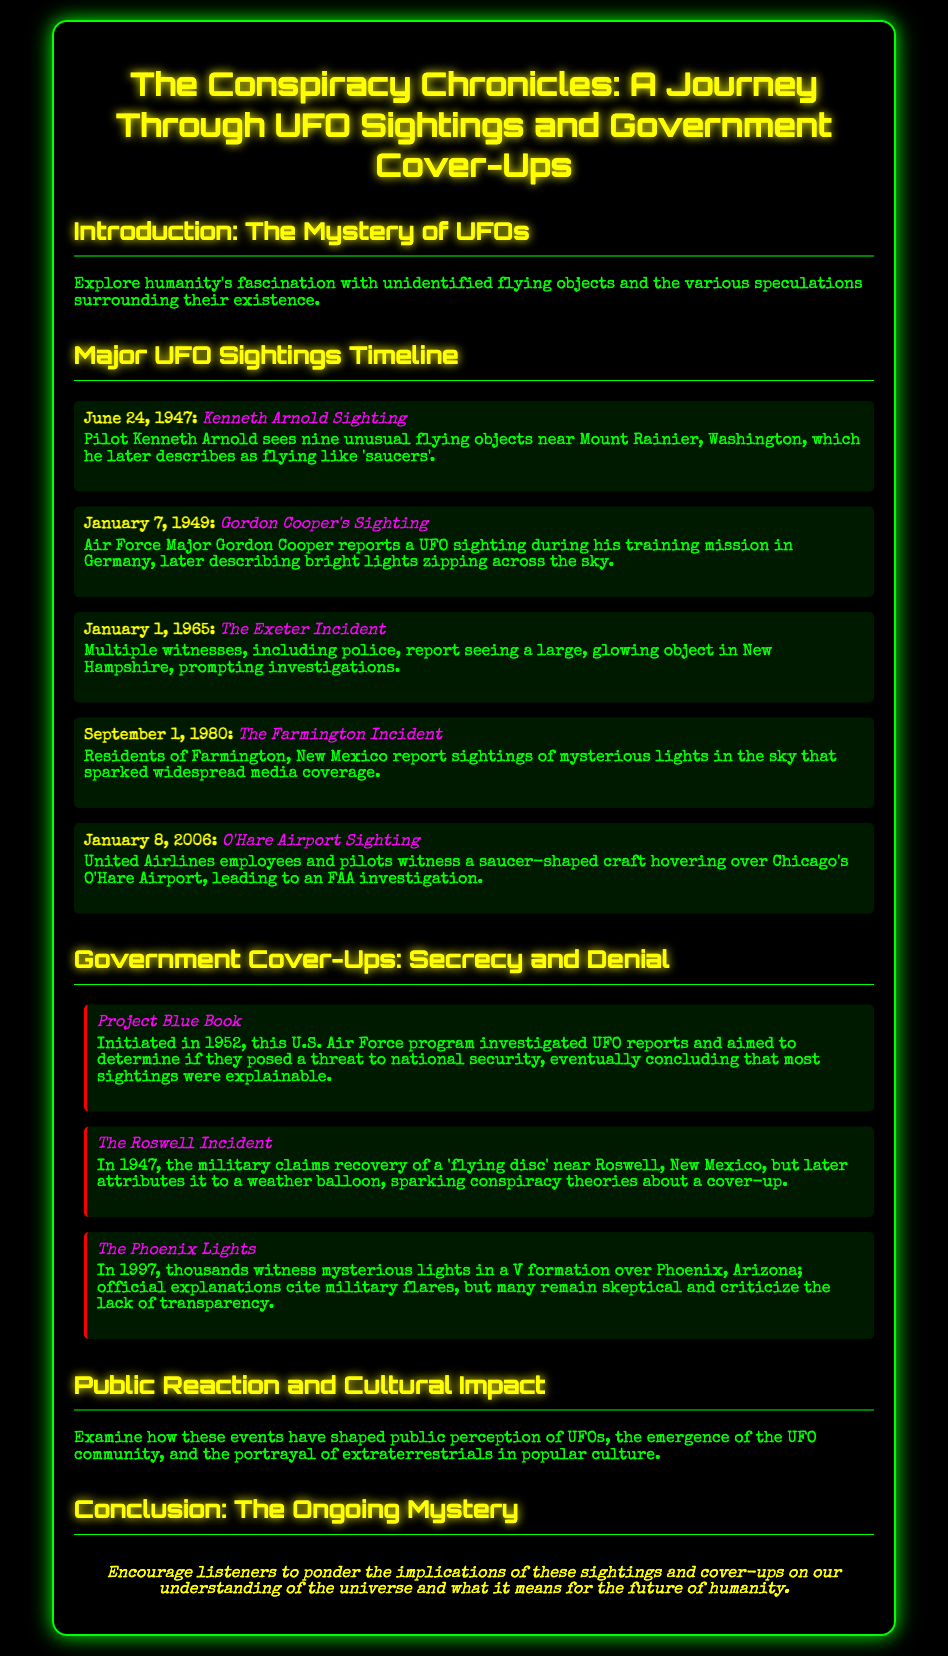what date did Kenneth Arnold report his sighting? Kenneth Arnold's sighting date is explicitly mentioned as June 24, 1947.
Answer: June 24, 1947 who reported the sighting during a training mission in Germany? The document states that Air Force Major Gordon Cooper reported a UFO sighting during his training mission in Germany.
Answer: Gordon Cooper how many witnesses reported the Exeter Incident? The document specifies that multiple witnesses, including police, reported the Exeter Incident.
Answer: Multiple what were the mysterious lights in New Mexico associated with? The description in the document mentions that the sightings in Farmington, New Mexico sparked widespread media coverage.
Answer: Media coverage what was concluded about most sightings in Project Blue Book? The document indicates that the conclusion of Project Blue Book was that most sightings were explainable.
Answer: Explainable what military explanation was given for the Roswell Incident? According to the document, the military later attributed the Roswell incident recovery to a weather balloon.
Answer: Weather balloon in what year did the Phoenix Lights occur? The document clearly states that the Phoenix Lights incident occurred in 1997.
Answer: 1997 what is the overarching theme of the conclusion? The conclusion encourages listeners to ponder the implications of sightings and cover-ups on our understanding of the universe.
Answer: Understanding of the universe 